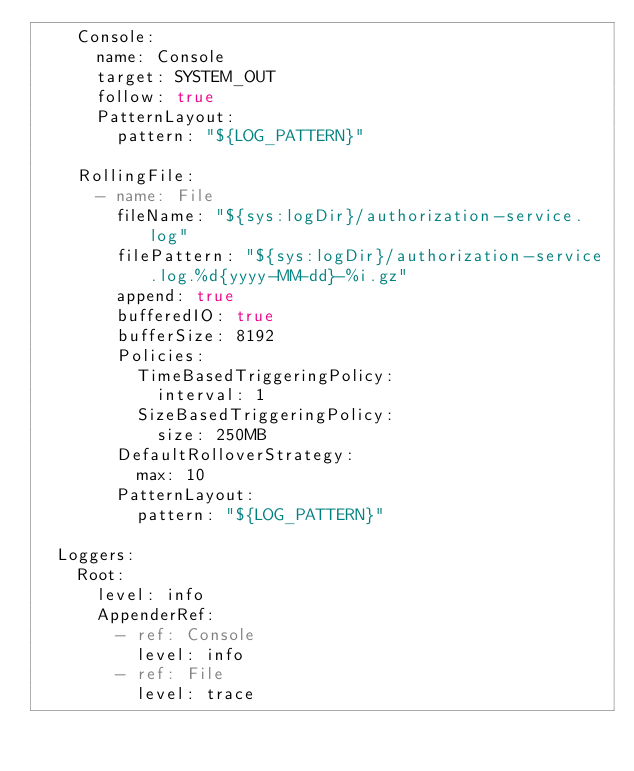Convert code to text. <code><loc_0><loc_0><loc_500><loc_500><_YAML_>    Console:
      name: Console
      target: SYSTEM_OUT
      follow: true
      PatternLayout:
        pattern: "${LOG_PATTERN}"

    RollingFile:
      - name: File
        fileName: "${sys:logDir}/authorization-service.log"
        filePattern: "${sys:logDir}/authorization-service.log.%d{yyyy-MM-dd}-%i.gz"
        append: true
        bufferedIO: true
        bufferSize: 8192
        Policies:
          TimeBasedTriggeringPolicy:
            interval: 1
          SizeBasedTriggeringPolicy:
            size: 250MB
        DefaultRolloverStrategy:
          max: 10
        PatternLayout:
          pattern: "${LOG_PATTERN}"

  Loggers:
    Root:
      level: info
      AppenderRef:
        - ref: Console
          level: info
        - ref: File
          level: trace
</code> 